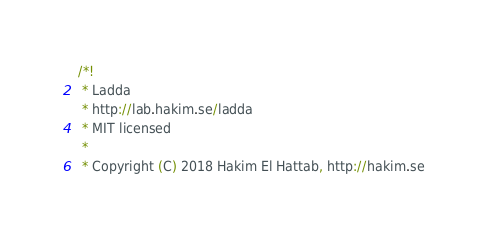<code> <loc_0><loc_0><loc_500><loc_500><_CSS_>/*!
 * Ladda
 * http://lab.hakim.se/ladda
 * MIT licensed
 *
 * Copyright (C) 2018 Hakim El Hattab, http://hakim.se</code> 